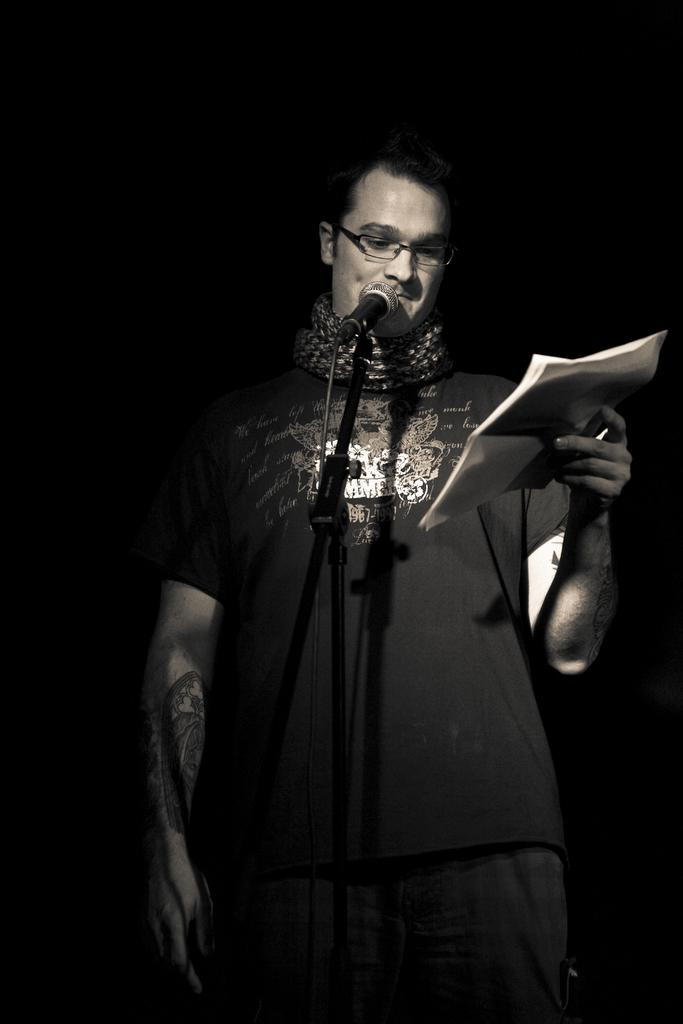What is the main object in the image? There is a mic with a stand and wire in the image. Who is present in the image? A man is standing behind the mic. What is the man holding in his hand? The man is holding papers in his hand. What can be seen on the man's face? The man is wearing spectacles. What is the color of the background in the image? The background of the image is black. Can you see any sea creatures swimming in the background of the image? There are no sea creatures visible in the image, as the background is black. How many grandmothers are present in the image? There are no grandmothers present in the image; it features a man standing behind a mic. 